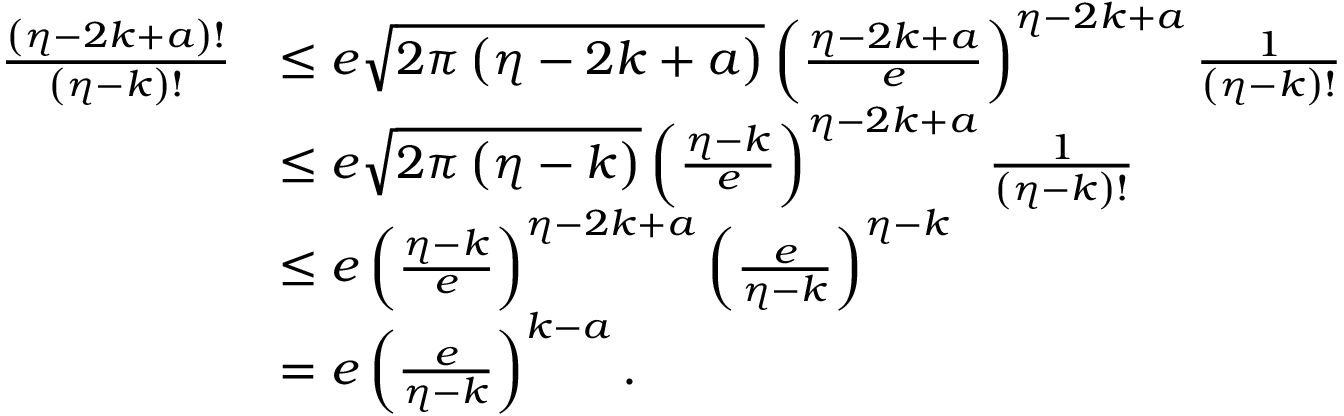Convert formula to latex. <formula><loc_0><loc_0><loc_500><loc_500>\begin{array} { r l } { \frac { \left ( \eta - 2 k + a \right ) ! } { \left ( \eta - k \right ) ! } } & { \leq e \sqrt { 2 \pi \left ( \eta - 2 k + a \right ) } \left ( \frac { \eta - 2 k + a } { e } \right ) ^ { \eta - 2 k + a } \frac { 1 } { \left ( \eta - k \right ) ! } } \\ & { \leq e \sqrt { 2 \pi \left ( \eta - k \right ) } \left ( \frac { \eta - k } { e } \right ) ^ { \eta - 2 k + a } \frac { 1 } { \left ( \eta - k \right ) ! } } \\ & { \leq e \left ( \frac { \eta - k } { e } \right ) ^ { \eta - 2 k + a } \left ( \frac { e } { \eta - k } \right ) ^ { \eta - k } } \\ & { = e \left ( \frac { e } { \eta - k } \right ) ^ { k - a } . } \end{array}</formula> 